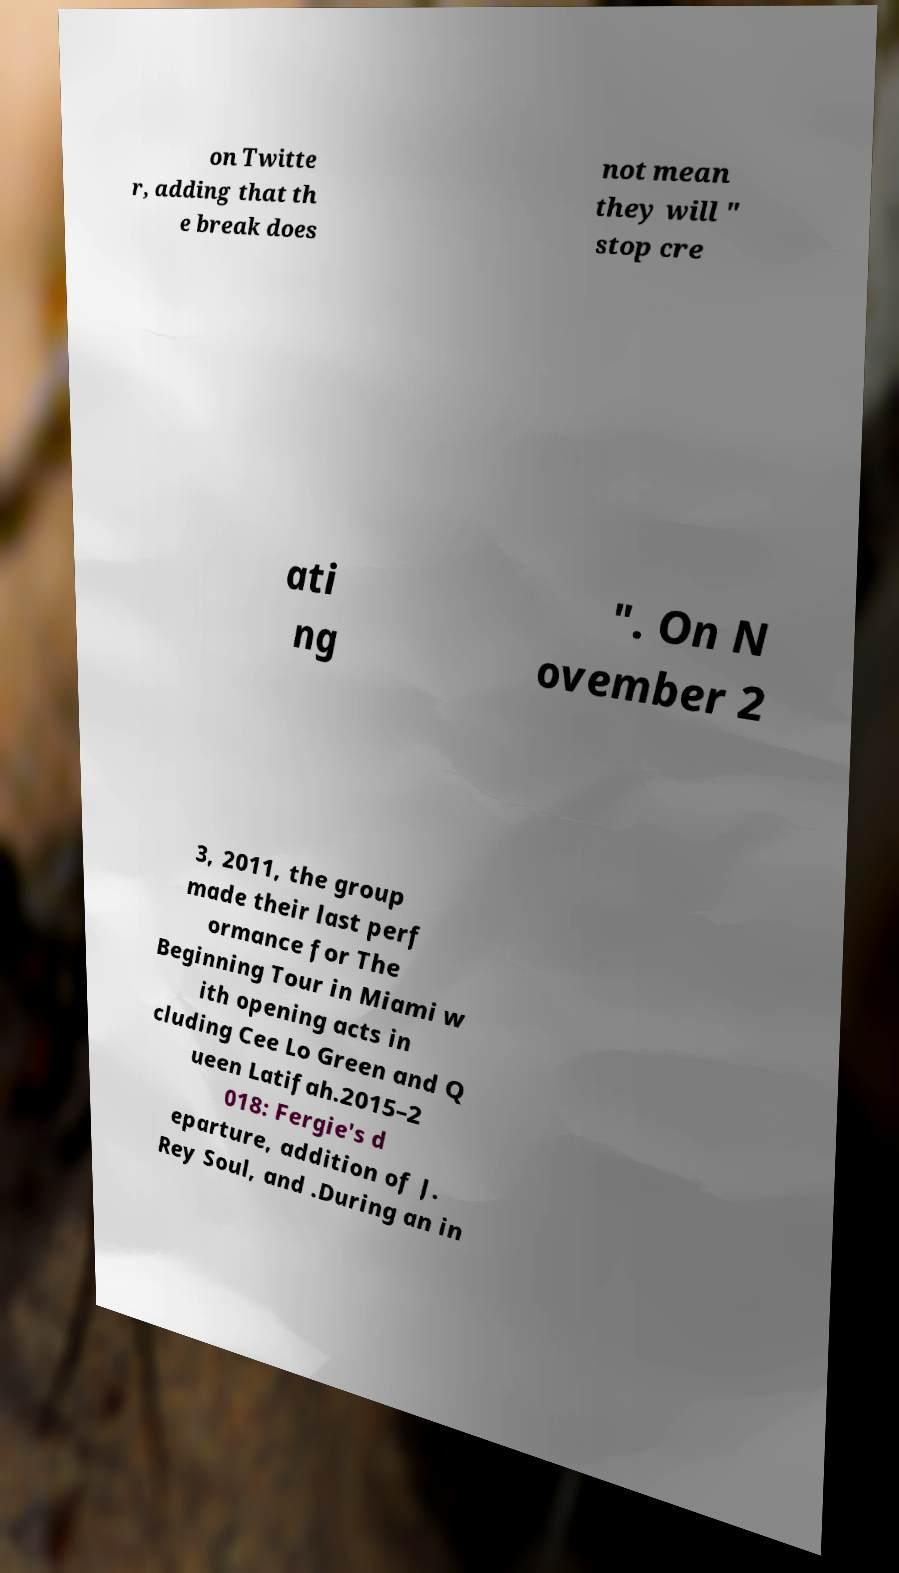I need the written content from this picture converted into text. Can you do that? on Twitte r, adding that th e break does not mean they will " stop cre ati ng ". On N ovember 2 3, 2011, the group made their last perf ormance for The Beginning Tour in Miami w ith opening acts in cluding Cee Lo Green and Q ueen Latifah.2015–2 018: Fergie's d eparture, addition of J. Rey Soul, and .During an in 